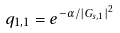Convert formula to latex. <formula><loc_0><loc_0><loc_500><loc_500>q _ { 1 , 1 } = e ^ { - \alpha / | G _ { s , 1 } | ^ { 2 } }</formula> 